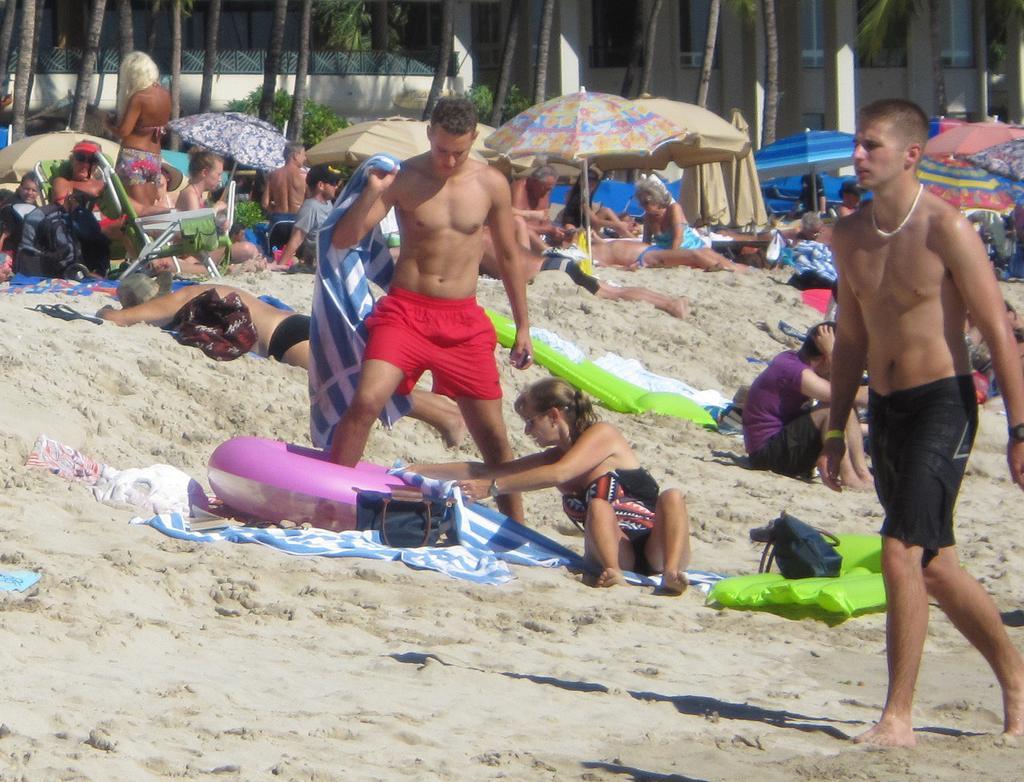In one or two sentences, can you explain what this image depicts? In this image we can see people on sand. There are umbrellas, trees. In the background of the image there is a building, plants. To the right side of the image there is a person walking. 